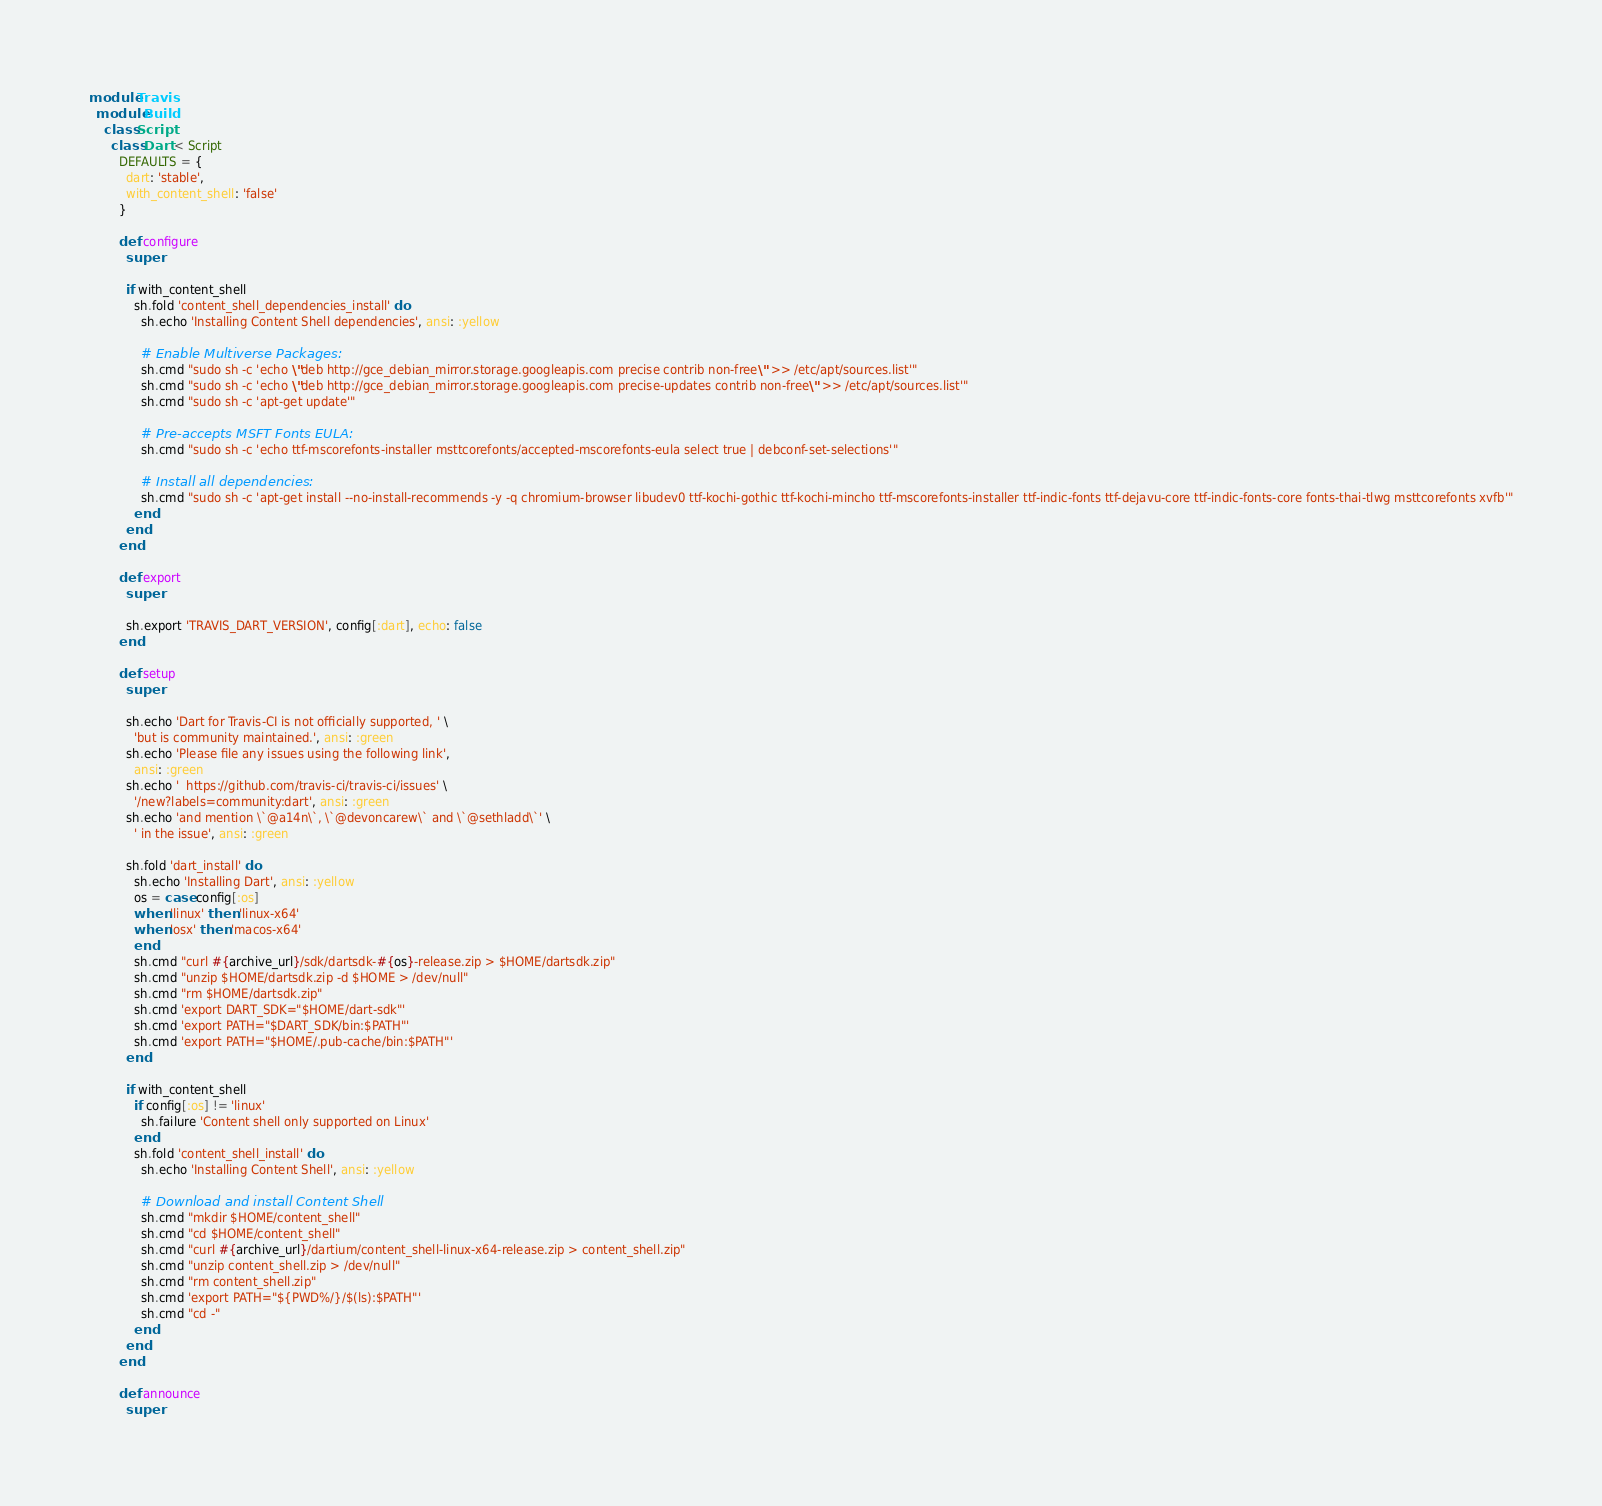<code> <loc_0><loc_0><loc_500><loc_500><_Ruby_>module Travis
  module Build
    class Script
      class Dart < Script
        DEFAULTS = {
          dart: 'stable',
          with_content_shell: 'false'
        }

        def configure
          super

          if with_content_shell
            sh.fold 'content_shell_dependencies_install' do
              sh.echo 'Installing Content Shell dependencies', ansi: :yellow

              # Enable Multiverse Packages:
              sh.cmd "sudo sh -c 'echo \"deb http://gce_debian_mirror.storage.googleapis.com precise contrib non-free\" >> /etc/apt/sources.list'"
              sh.cmd "sudo sh -c 'echo \"deb http://gce_debian_mirror.storage.googleapis.com precise-updates contrib non-free\" >> /etc/apt/sources.list'"
              sh.cmd "sudo sh -c 'apt-get update'"

              # Pre-accepts MSFT Fonts EULA:
              sh.cmd "sudo sh -c 'echo ttf-mscorefonts-installer msttcorefonts/accepted-mscorefonts-eula select true | debconf-set-selections'"

              # Install all dependencies:
              sh.cmd "sudo sh -c 'apt-get install --no-install-recommends -y -q chromium-browser libudev0 ttf-kochi-gothic ttf-kochi-mincho ttf-mscorefonts-installer ttf-indic-fonts ttf-dejavu-core ttf-indic-fonts-core fonts-thai-tlwg msttcorefonts xvfb'"
            end
          end
        end

        def export
          super

          sh.export 'TRAVIS_DART_VERSION', config[:dart], echo: false
        end

        def setup
          super

          sh.echo 'Dart for Travis-CI is not officially supported, ' \
            'but is community maintained.', ansi: :green
          sh.echo 'Please file any issues using the following link',
            ansi: :green
          sh.echo '  https://github.com/travis-ci/travis-ci/issues' \
            '/new?labels=community:dart', ansi: :green
          sh.echo 'and mention \`@a14n\`, \`@devoncarew\` and \`@sethladd\`' \
            ' in the issue', ansi: :green

          sh.fold 'dart_install' do
            sh.echo 'Installing Dart', ansi: :yellow
            os = case config[:os]
            when 'linux' then 'linux-x64'
            when 'osx' then 'macos-x64'
            end
            sh.cmd "curl #{archive_url}/sdk/dartsdk-#{os}-release.zip > $HOME/dartsdk.zip"
            sh.cmd "unzip $HOME/dartsdk.zip -d $HOME > /dev/null"
            sh.cmd "rm $HOME/dartsdk.zip"
            sh.cmd 'export DART_SDK="$HOME/dart-sdk"'
            sh.cmd 'export PATH="$DART_SDK/bin:$PATH"'
            sh.cmd 'export PATH="$HOME/.pub-cache/bin:$PATH"'
          end

          if with_content_shell
            if config[:os] != 'linux'
              sh.failure 'Content shell only supported on Linux'
            end
            sh.fold 'content_shell_install' do
              sh.echo 'Installing Content Shell', ansi: :yellow

              # Download and install Content Shell
              sh.cmd "mkdir $HOME/content_shell"
              sh.cmd "cd $HOME/content_shell"
              sh.cmd "curl #{archive_url}/dartium/content_shell-linux-x64-release.zip > content_shell.zip"
              sh.cmd "unzip content_shell.zip > /dev/null"
              sh.cmd "rm content_shell.zip"
              sh.cmd 'export PATH="${PWD%/}/$(ls):$PATH"'
              sh.cmd "cd -"
            end
          end
        end

        def announce
          super
</code> 